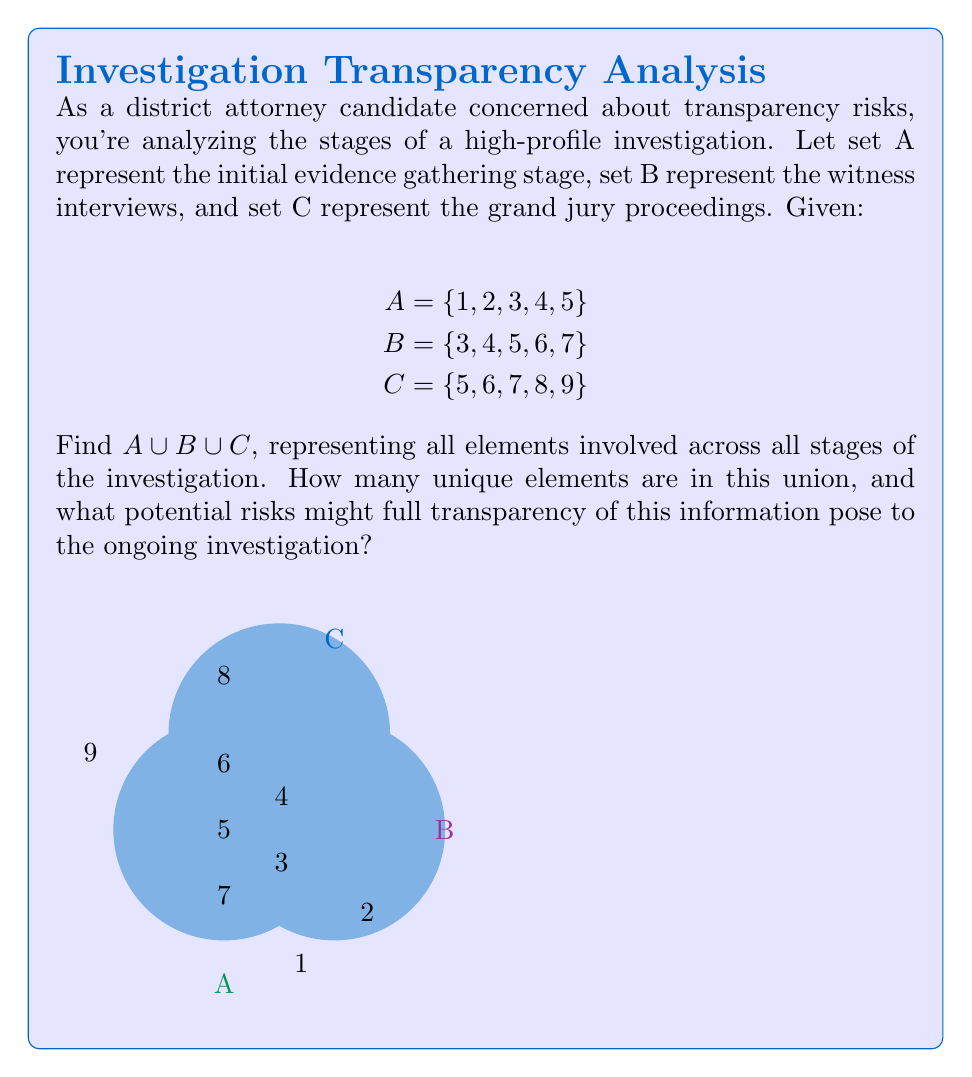Solve this math problem. To find $A \cup B \cup C$, we need to identify all unique elements that appear in at least one of the sets:

1. Start with set A: {1, 2, 3, 4, 5}
2. Add unique elements from set B: 6, 7
3. Add unique elements from set C: 8, 9

Therefore, $A \cup B \cup C = \{1, 2, 3, 4, 5, 6, 7, 8, 9\}$

To count the number of unique elements:
$$|A \cup B \cup C| = 9$$

Regarding potential risks of full transparency:

1. Revealing all elements could compromise the integrity of the investigation by alerting suspects or witnesses prematurely.
2. It might lead to evidence tampering or witness intimidation if the extent of the investigation becomes known.
3. The grand jury proceedings (set C) are typically confidential, and their disclosure could violate legal procedures.
4. Full transparency might reveal investigative techniques or sources, potentially hampering future investigations.
Answer: $A \cup B \cup C = \{1, 2, 3, 4, 5, 6, 7, 8, 9\}$; 9 elements 